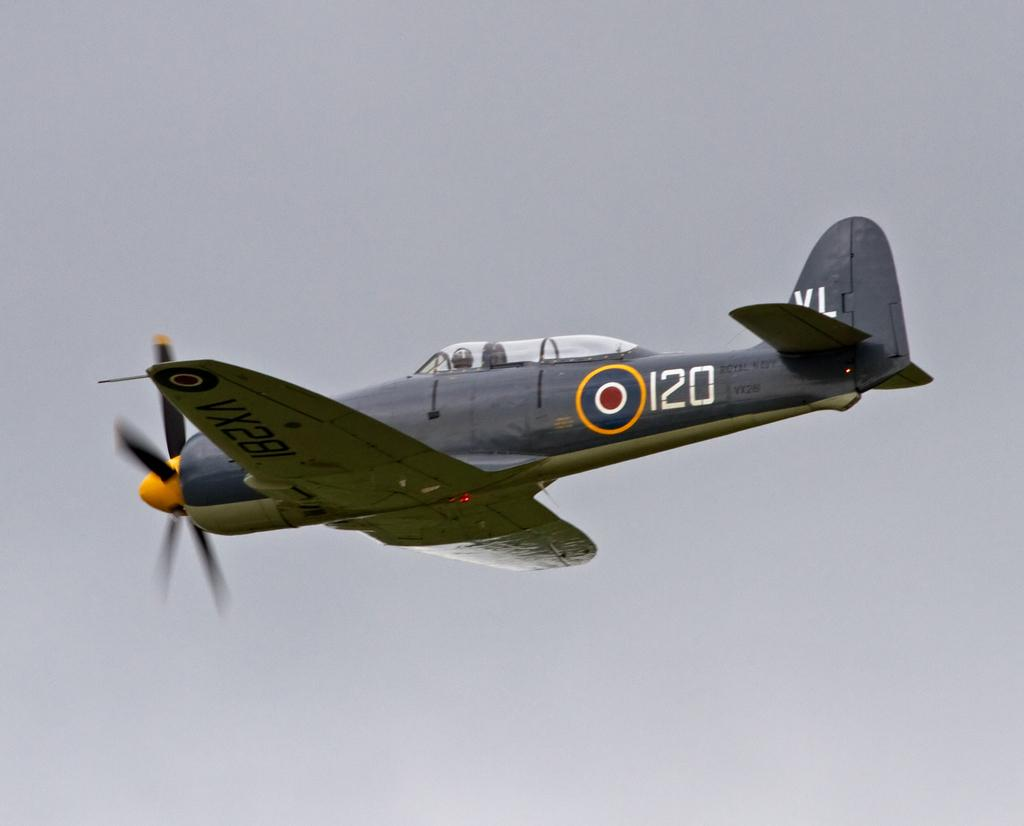<image>
Provide a brief description of the given image. a yellow and grey airplane with the number 120 on the back. 